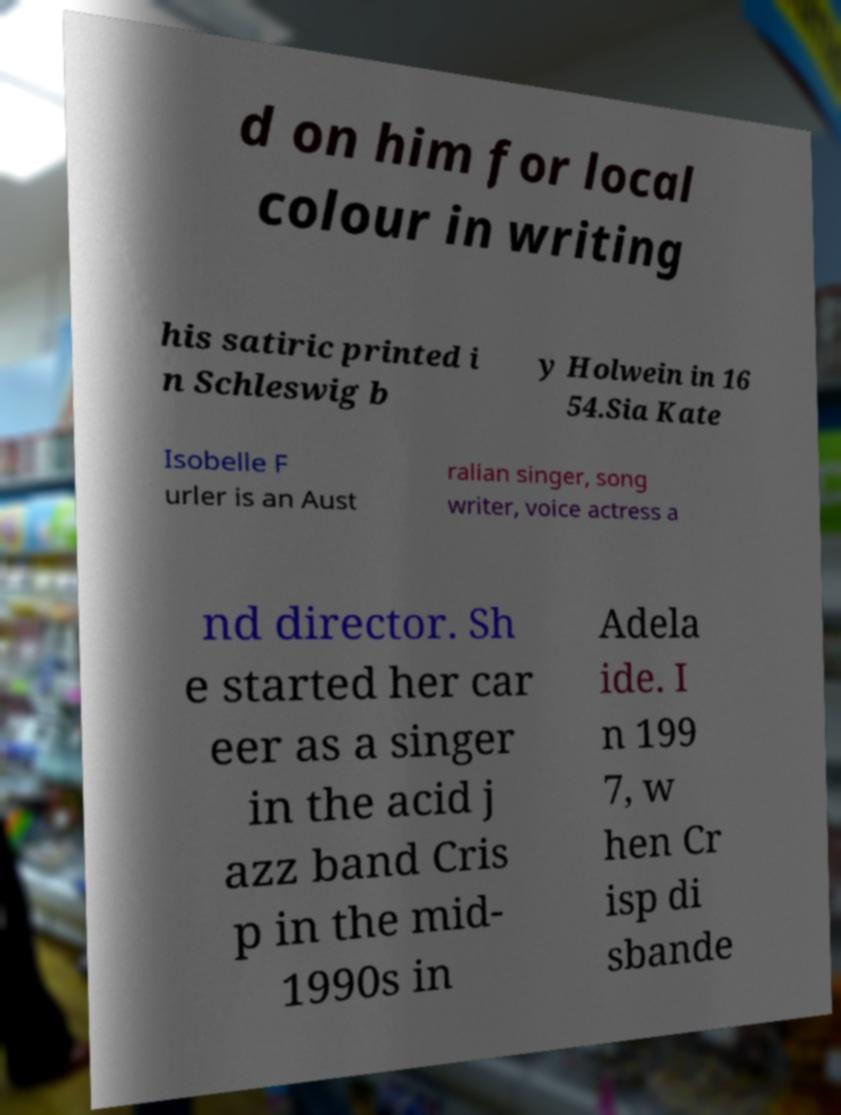Could you extract and type out the text from this image? d on him for local colour in writing his satiric printed i n Schleswig b y Holwein in 16 54.Sia Kate Isobelle F urler is an Aust ralian singer, song writer, voice actress a nd director. Sh e started her car eer as a singer in the acid j azz band Cris p in the mid- 1990s in Adela ide. I n 199 7, w hen Cr isp di sbande 